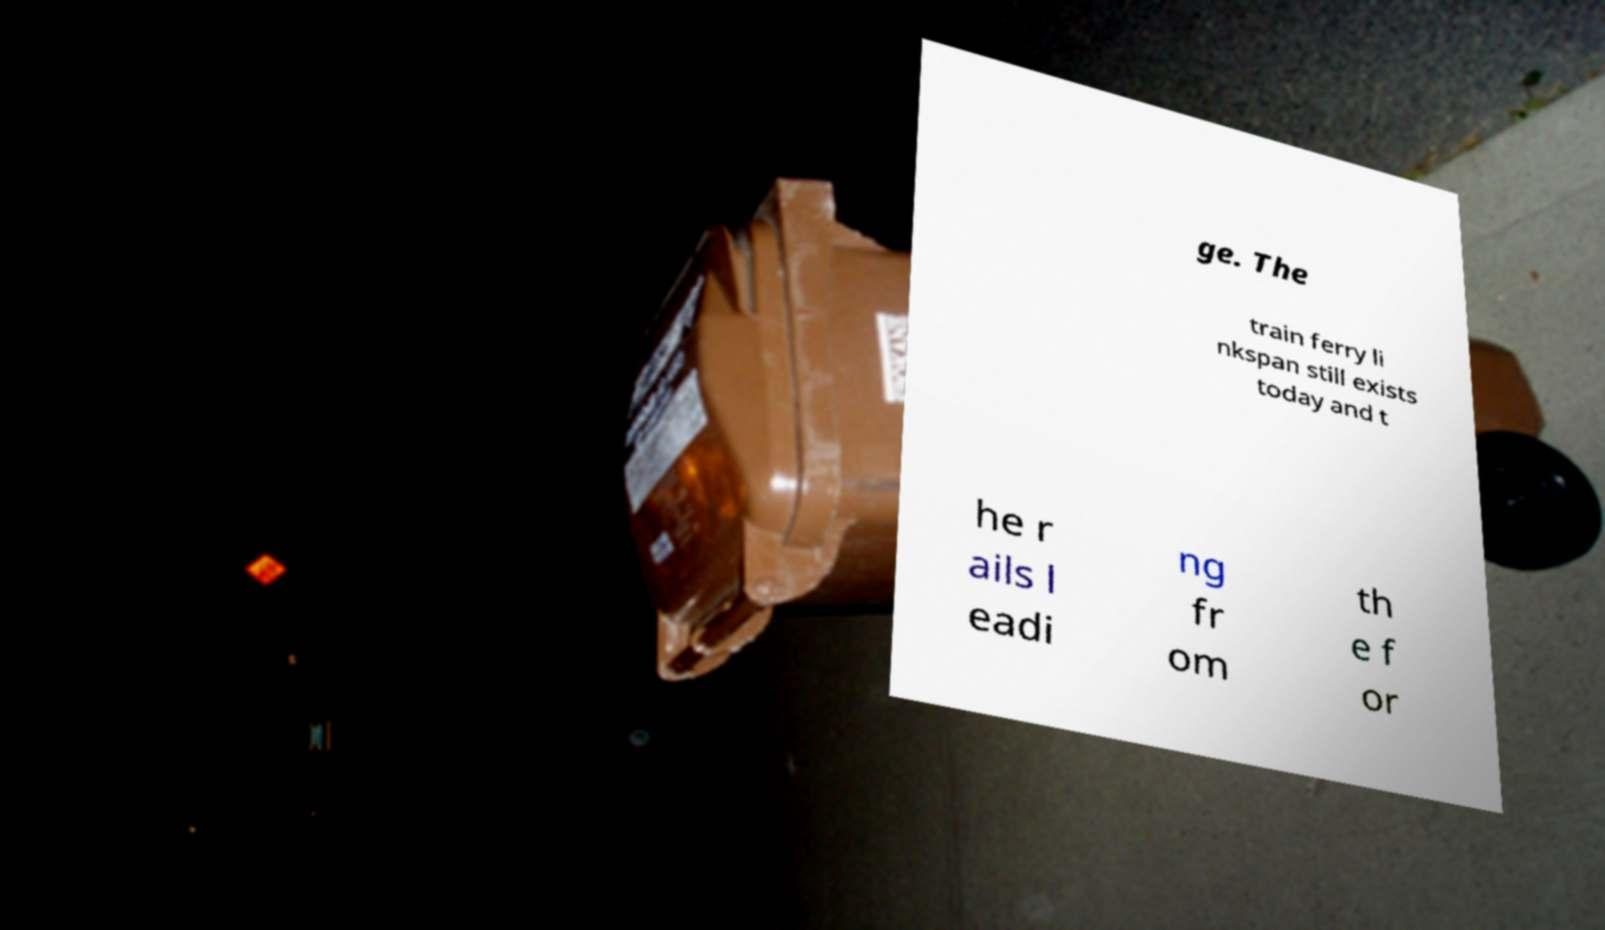Can you read and provide the text displayed in the image?This photo seems to have some interesting text. Can you extract and type it out for me? ge. The train ferry li nkspan still exists today and t he r ails l eadi ng fr om th e f or 